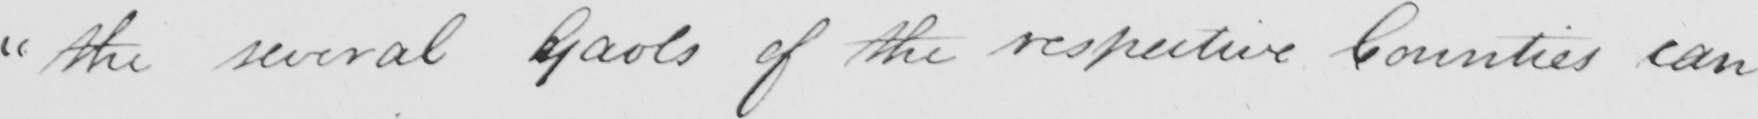What does this handwritten line say? " the several Goals of the respective Counties can 